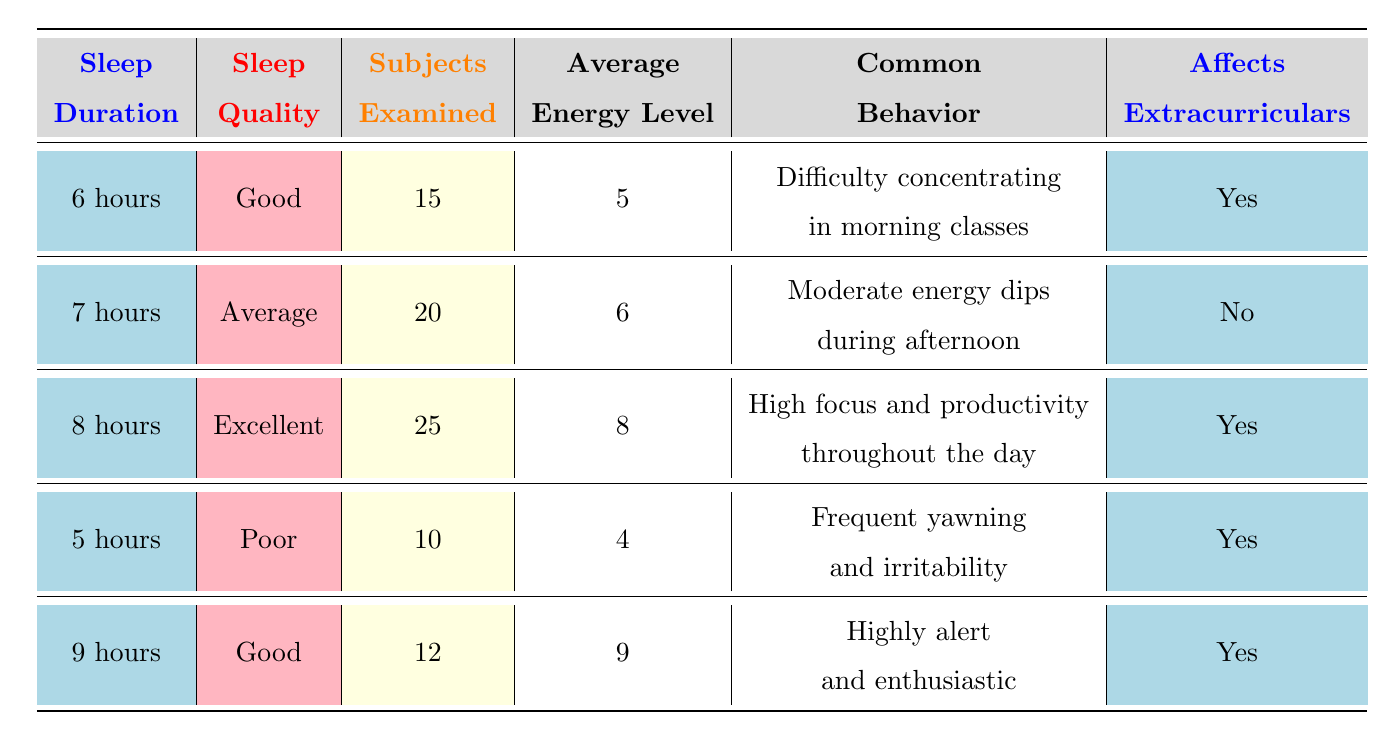What is the average energy level for 9 hours of sleep? The table lists the average energy level for each sleep duration. For 9 hours of sleep, the average energy level is 9.
Answer: 9 How many subjects were examined for 5 hours of sleep? According to the table, 10 subjects were examined for the duration of 5 hours of sleep.
Answer: 10 What is the common behavior for those who sleep for 6 hours? The table indicates that the common behavior for people who sleep for 6 hours is "Difficulty concentrating in morning classes."
Answer: Difficulty concentrating in morning classes Is there a relationship between sleep quality and average energy level? From the table, we can see that better sleep quality (Excellent) leads to higher energy levels (8 for 8 hours). In contrast, with Poor sleep quality (4 for 5 hours), the energy level drops. This suggests a positive relationship.
Answer: Yes What is the total number of subjects examined across all sleep durations? To find the total, we add the subjects examined: 15 (6 hours) + 20 (7 hours) + 25 (8 hours) + 10 (5 hours) + 12 (9 hours) = 92.
Answer: 92 Does sleeping for 7 hours affect extracurricular activities? The table states that for 7 hours of sleep, it says "No" under affects extracurriculars. Therefore, it does not affect extracurricular activities.
Answer: No What is the average energy level for those who sleep 5 hours compared to those who sleep 9 hours? The average energy level for 5 hours is 4 and for 9 hours is 9. The difference is 9 - 4 = 5, indicating that those who sleep 9 hours have a higher average energy level.
Answer: 5 How many subjects reported high focus and productivity and what quality of sleep did they have? The table shows that 25 subjects reported high focus and productivity for 8 hours of sleep, which is classified as Excellent quality of sleep.
Answer: 25 subjects, Excellent quality 